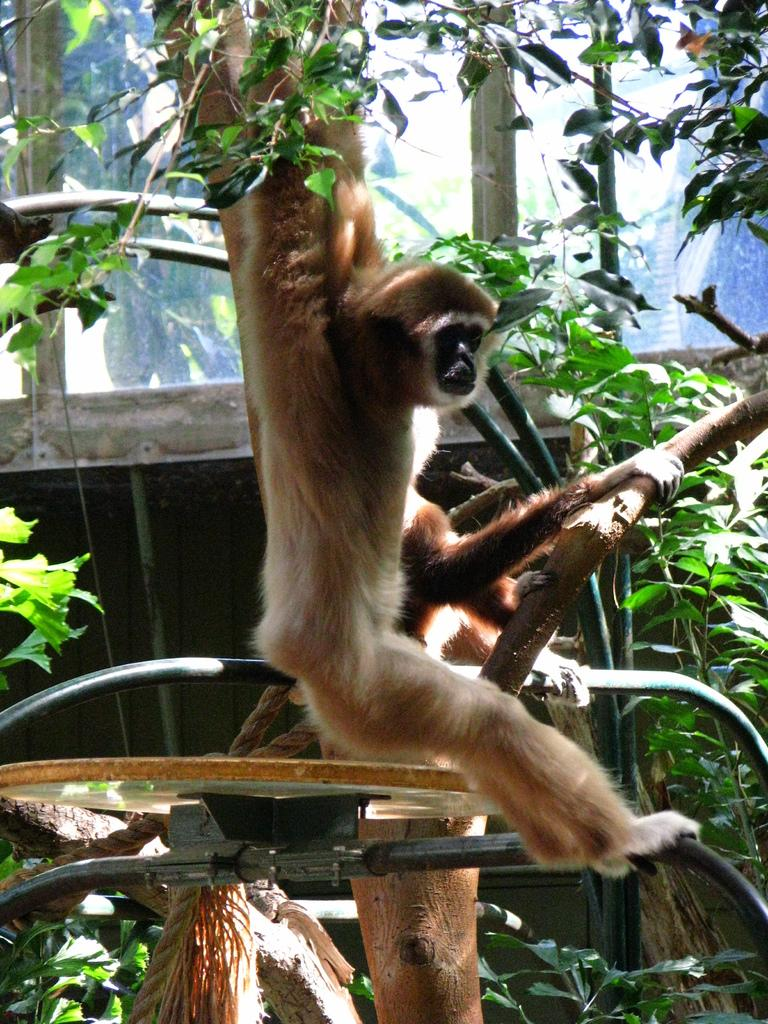What animal is present in the image? There is a monkey in the image. What is the monkey doing in the image? The monkey is hanging on a tree. What can be seen in the background of the image? There are trees, plants, and a wall in the background of the image. What type of market can be seen in the image? There is no market present in the image; it features a monkey hanging on a tree with a background of trees, plants, and a wall. 